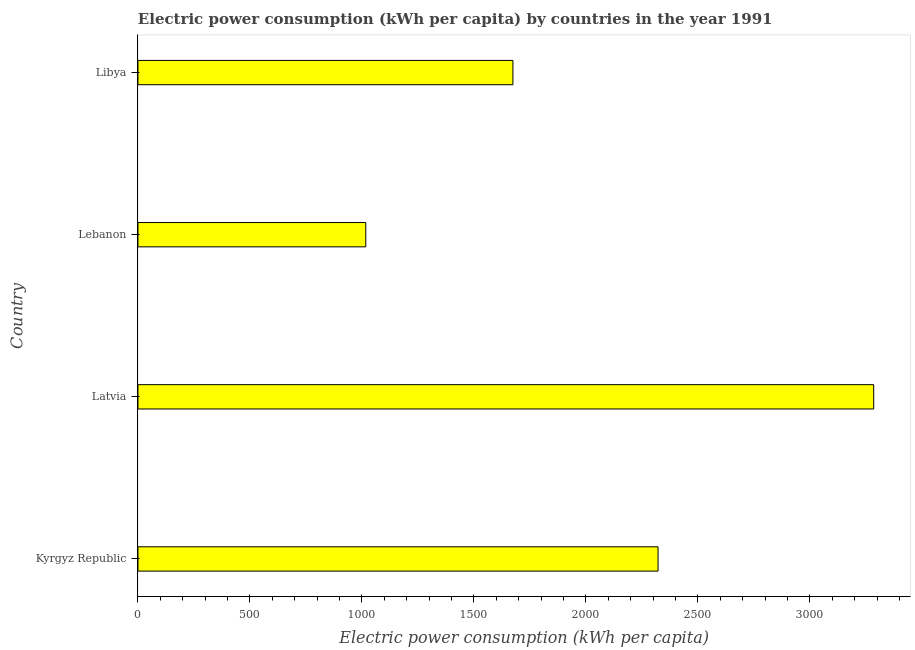What is the title of the graph?
Your answer should be very brief. Electric power consumption (kWh per capita) by countries in the year 1991. What is the label or title of the X-axis?
Your answer should be very brief. Electric power consumption (kWh per capita). What is the electric power consumption in Lebanon?
Offer a terse response. 1017.27. Across all countries, what is the maximum electric power consumption?
Make the answer very short. 3285.32. Across all countries, what is the minimum electric power consumption?
Keep it short and to the point. 1017.27. In which country was the electric power consumption maximum?
Your answer should be compact. Latvia. In which country was the electric power consumption minimum?
Your answer should be compact. Lebanon. What is the sum of the electric power consumption?
Your answer should be very brief. 8299.22. What is the difference between the electric power consumption in Kyrgyz Republic and Lebanon?
Ensure brevity in your answer.  1305.07. What is the average electric power consumption per country?
Your answer should be very brief. 2074.8. What is the median electric power consumption?
Give a very brief answer. 1998.32. In how many countries, is the electric power consumption greater than 2300 kWh per capita?
Provide a short and direct response. 2. What is the ratio of the electric power consumption in Latvia to that in Libya?
Provide a succinct answer. 1.96. What is the difference between the highest and the second highest electric power consumption?
Give a very brief answer. 962.98. Is the sum of the electric power consumption in Lebanon and Libya greater than the maximum electric power consumption across all countries?
Make the answer very short. No. What is the difference between the highest and the lowest electric power consumption?
Your answer should be compact. 2268.05. How many bars are there?
Your answer should be very brief. 4. Are all the bars in the graph horizontal?
Ensure brevity in your answer.  Yes. What is the Electric power consumption (kWh per capita) in Kyrgyz Republic?
Provide a succinct answer. 2322.34. What is the Electric power consumption (kWh per capita) of Latvia?
Make the answer very short. 3285.32. What is the Electric power consumption (kWh per capita) of Lebanon?
Provide a succinct answer. 1017.27. What is the Electric power consumption (kWh per capita) in Libya?
Ensure brevity in your answer.  1674.29. What is the difference between the Electric power consumption (kWh per capita) in Kyrgyz Republic and Latvia?
Offer a very short reply. -962.98. What is the difference between the Electric power consumption (kWh per capita) in Kyrgyz Republic and Lebanon?
Make the answer very short. 1305.07. What is the difference between the Electric power consumption (kWh per capita) in Kyrgyz Republic and Libya?
Provide a short and direct response. 648.05. What is the difference between the Electric power consumption (kWh per capita) in Latvia and Lebanon?
Make the answer very short. 2268.05. What is the difference between the Electric power consumption (kWh per capita) in Latvia and Libya?
Keep it short and to the point. 1611.02. What is the difference between the Electric power consumption (kWh per capita) in Lebanon and Libya?
Keep it short and to the point. -657.03. What is the ratio of the Electric power consumption (kWh per capita) in Kyrgyz Republic to that in Latvia?
Offer a terse response. 0.71. What is the ratio of the Electric power consumption (kWh per capita) in Kyrgyz Republic to that in Lebanon?
Offer a terse response. 2.28. What is the ratio of the Electric power consumption (kWh per capita) in Kyrgyz Republic to that in Libya?
Offer a very short reply. 1.39. What is the ratio of the Electric power consumption (kWh per capita) in Latvia to that in Lebanon?
Your answer should be compact. 3.23. What is the ratio of the Electric power consumption (kWh per capita) in Latvia to that in Libya?
Offer a terse response. 1.96. What is the ratio of the Electric power consumption (kWh per capita) in Lebanon to that in Libya?
Your response must be concise. 0.61. 